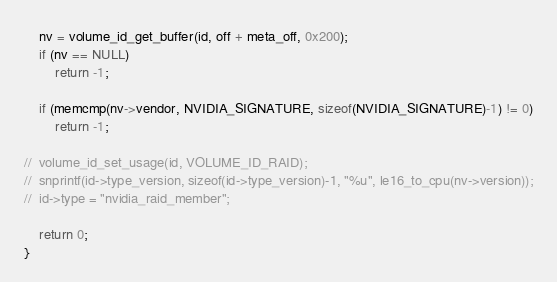<code> <loc_0><loc_0><loc_500><loc_500><_C_>	nv = volume_id_get_buffer(id, off + meta_off, 0x200);
	if (nv == NULL)
		return -1;

	if (memcmp(nv->vendor, NVIDIA_SIGNATURE, sizeof(NVIDIA_SIGNATURE)-1) != 0)
		return -1;

//	volume_id_set_usage(id, VOLUME_ID_RAID);
//	snprintf(id->type_version, sizeof(id->type_version)-1, "%u", le16_to_cpu(nv->version));
//	id->type = "nvidia_raid_member";

	return 0;
}
</code> 